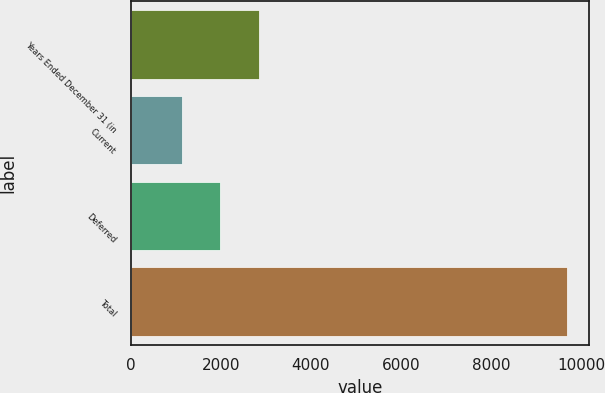<chart> <loc_0><loc_0><loc_500><loc_500><bar_chart><fcel>Years Ended December 31 (in<fcel>Current<fcel>Deferred<fcel>Total<nl><fcel>2844.6<fcel>1135<fcel>1989.8<fcel>9683<nl></chart> 